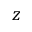<formula> <loc_0><loc_0><loc_500><loc_500>z</formula> 